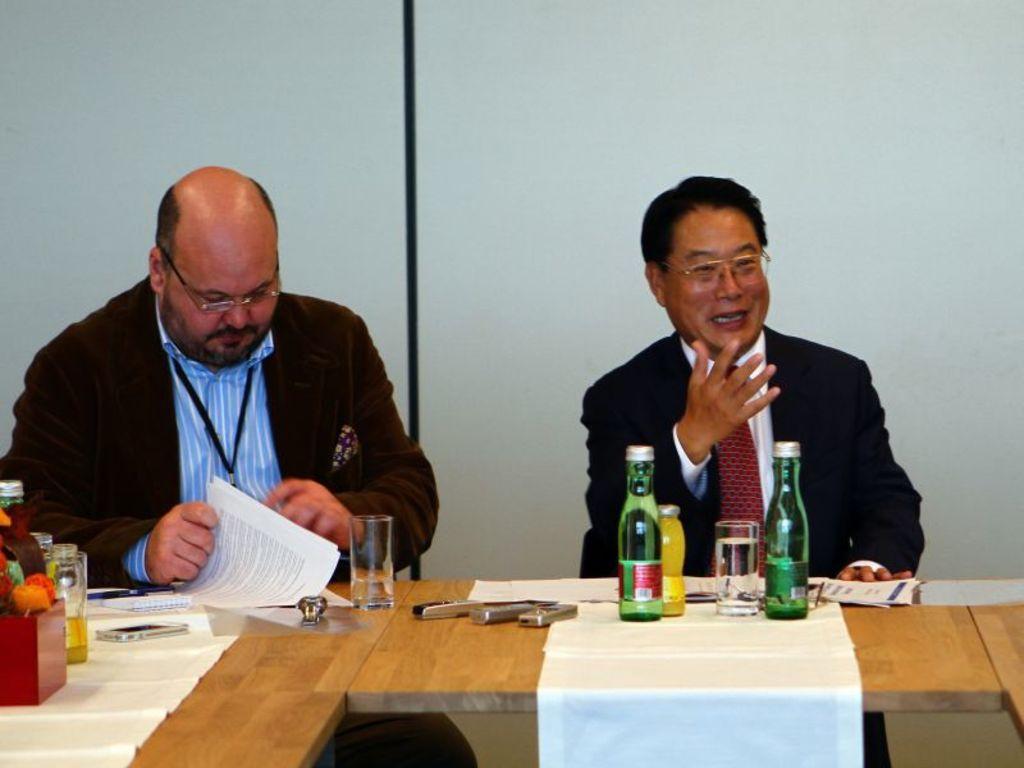How would you summarize this image in a sentence or two? In this picture we can see two men sitting on chair and in front of them there is table and on table we can see bottle, glass,mobile, papers, vase and in background we can see wall. 